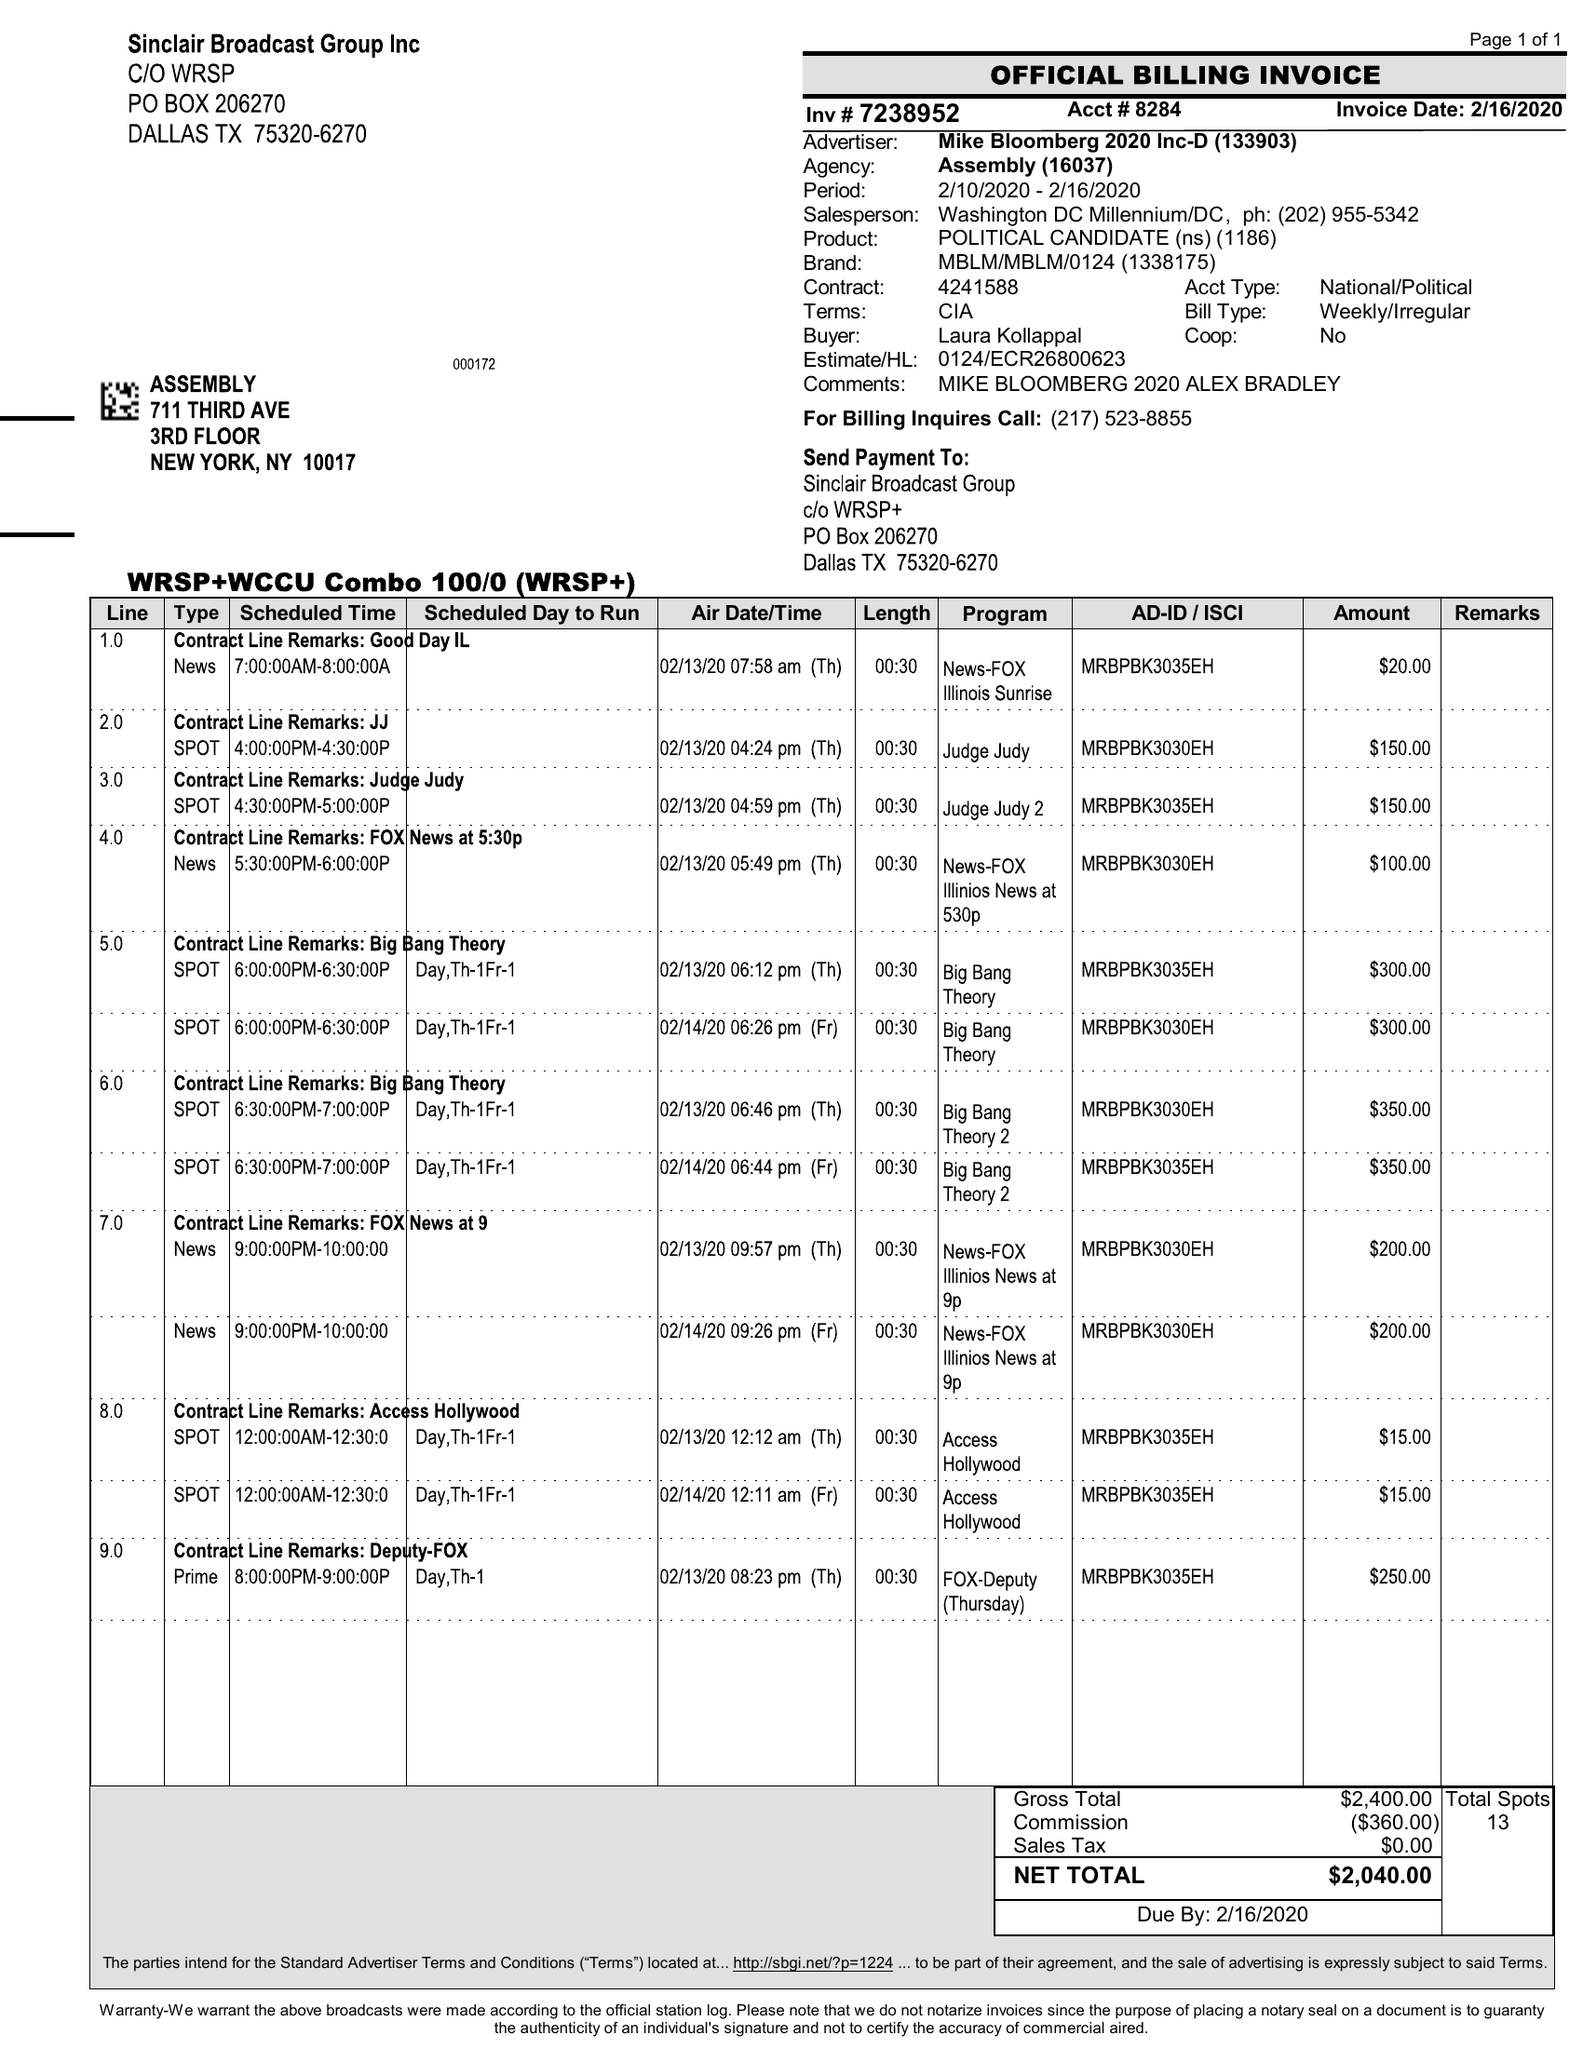What is the value for the flight_to?
Answer the question using a single word or phrase. 02/16/20 